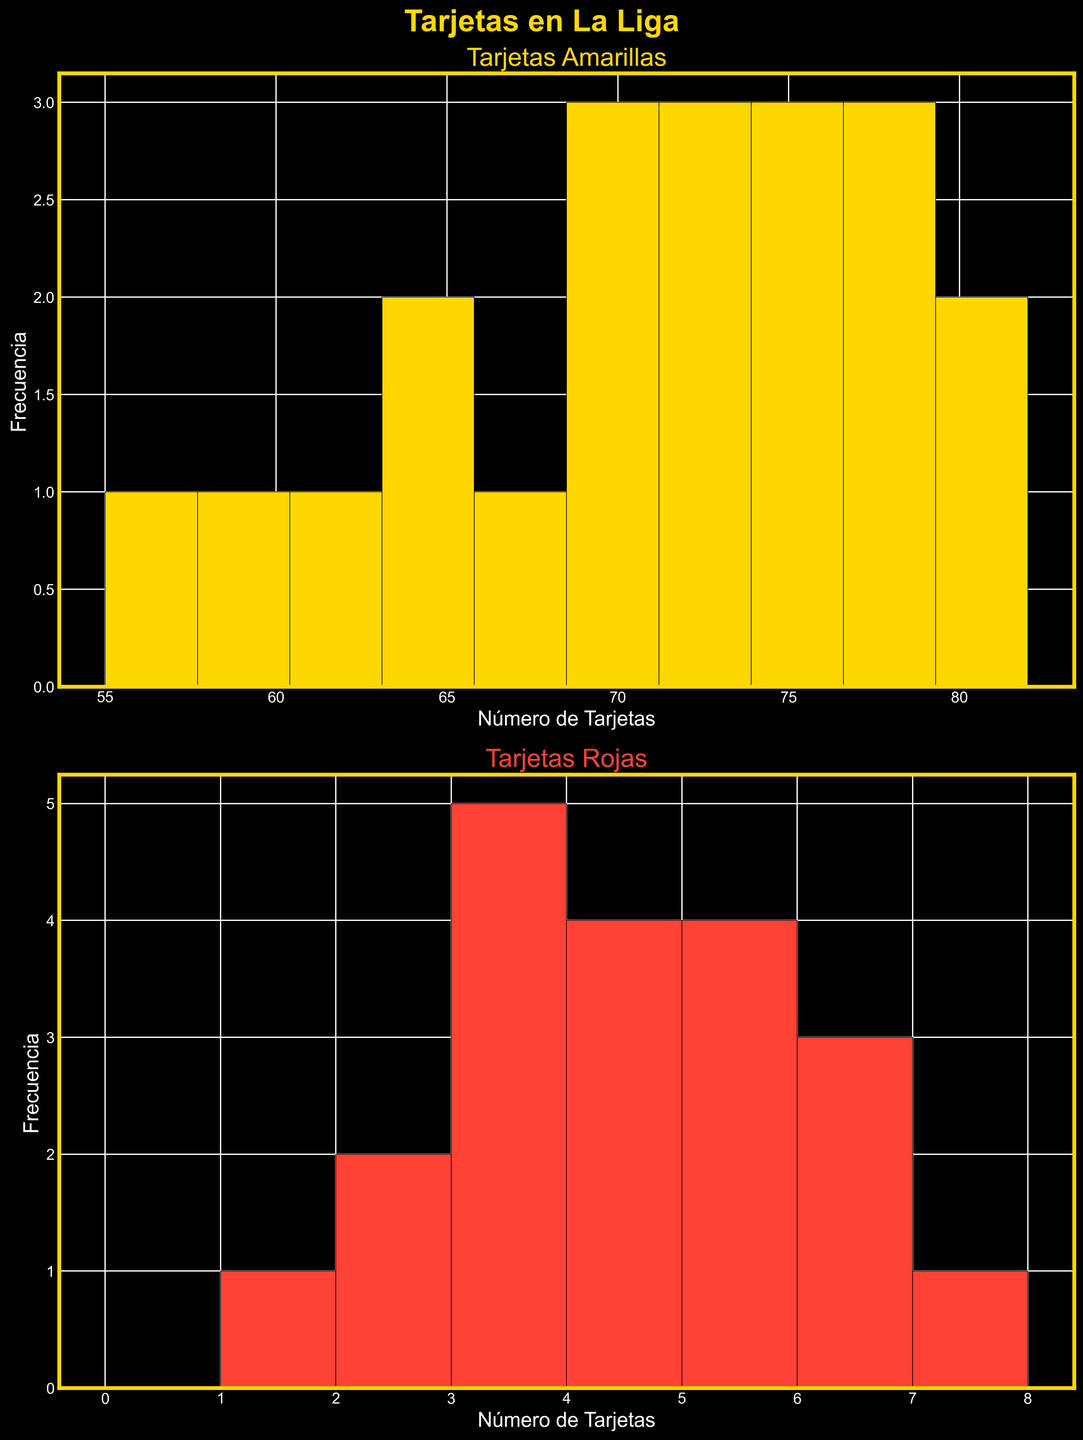¿Cuál es el título de la figura? El título de la figura está ubicado en la parte superior y es "Tarjetas en La Liga".
Answer: Tarjetas en La Liga ¿Cuántas tarjetas amarillas son más frecuentes? Observando el histograma de las tarjetas amarillas, el intervalo con mayor altura es 70-75, lo que significa que este rango es el más frecuente.
Answer: 70-75 ¿Cuántas tarjetas rojas son menos frecuentes? El histograma de las tarjetas rojas muestra que el intervalo 0-1 tiene la menor frecuencia, ya que tiene la barra más baja.
Answer: 0-1 ¿Hay más equipos con 3 o con 4 tarjetas rojas? Observando la altura de las barras para 3 y 4 tarjetas rojas en el histograma, la barra de 4 es más alta, lo que significa que más equipos tienen 4 tarjetas rojas.
Answer: 4 ¿Qué equipo tiene el mayor número de tarjetas amarillas y cuántas tiene? El equipo con mayores tarjetas amarillas es Getafe, con 82 tarjetas.
Answer: Getafe, 82 ¿Cuántos equipos tienen entre 70 y 80 tarjetas amarillas? Contando las barras dentro del rango de 70 a 80 en el histograma de las tarjetas amarillas, hay 7 equipos.
Answer: 7 ¿Cuál es la frecuencia de equipos que tienen exactamente 6 tarjetas rojas? La barra correspondiente al número 6 en el histograma de las tarjetas rojas muestra una frecuencia de 4.
Answer: 4 ¿Cómo se compara el equipo con más tarjetas amarillas con el equipo con menos tarjetas amarillas? Getafe tiene 82 tarjetas amarillas, mientras que Real Sociedad tiene 55, así que Getafe tiene 27 tarjetas más.
Answer: Getafe tiene 27 más ¿Cuál es la frecuencia de equipos con más de 75 tarjetas amarillas? Contando las barras de las tarjetas amarillas a partir del intervalo 75-80 hacia arriba, hay 5 equipos.
Answer: 5 